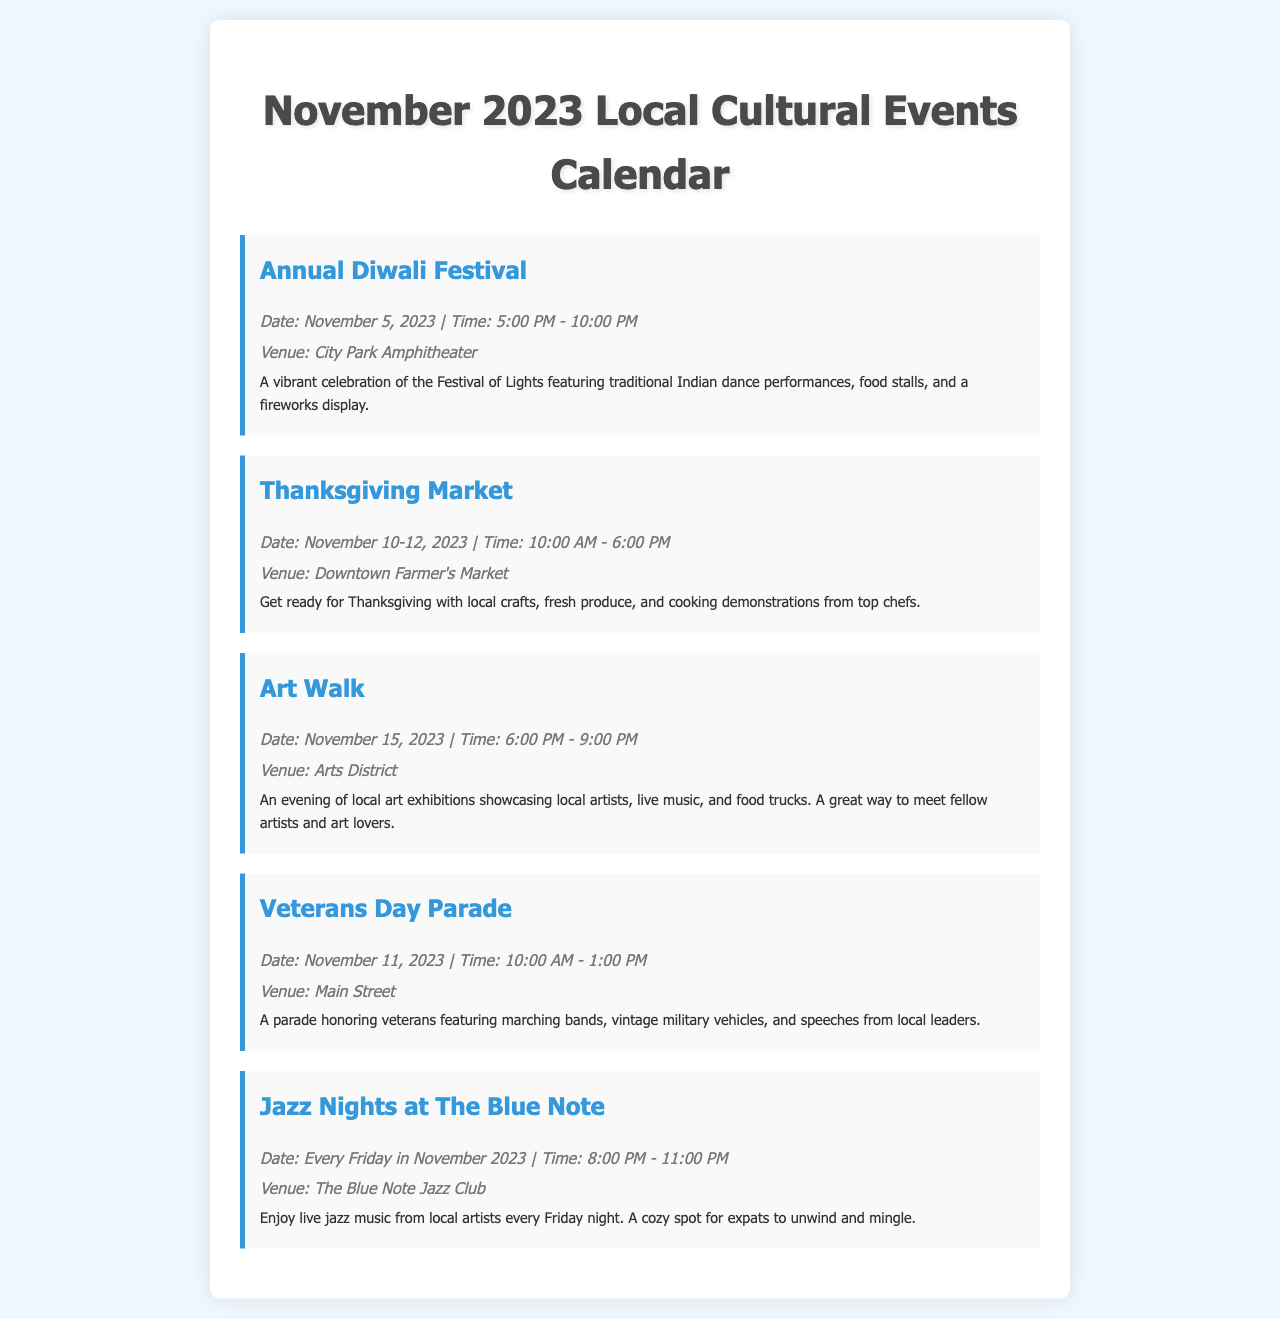what is the date of the Annual Diwali Festival? The document states the Annual Diwali Festival is on November 5, 2023.
Answer: November 5, 2023 where is the Thanksgiving Market being held? According to the document, the Thanksgiving Market is located at the Downtown Farmer's Market.
Answer: Downtown Farmer's Market how many days will the Thanksgiving Market run? The document mentions that the Thanksgiving Market runs for three days, from November 10 to November 12.
Answer: 3 days what time does Jazz Nights at The Blue Note start? The document specifies that Jazz Nights at The Blue Note starts at 8:00 PM.
Answer: 8:00 PM which event takes place on Veterans Day? The document indicates that the Veterans Day Parade occurs on November 11, 2023.
Answer: Veterans Day Parade how many events are listed in the document? The document lists five events in total.
Answer: 5 events what is a feature of the Annual Diwali Festival? The document describes a vibrant celebration including traditional Indian dance performances.
Answer: Traditional Indian dance performances which venue is hosting the Art Walk? The document states that the Art Walk is held in the Arts District.
Answer: Arts District 